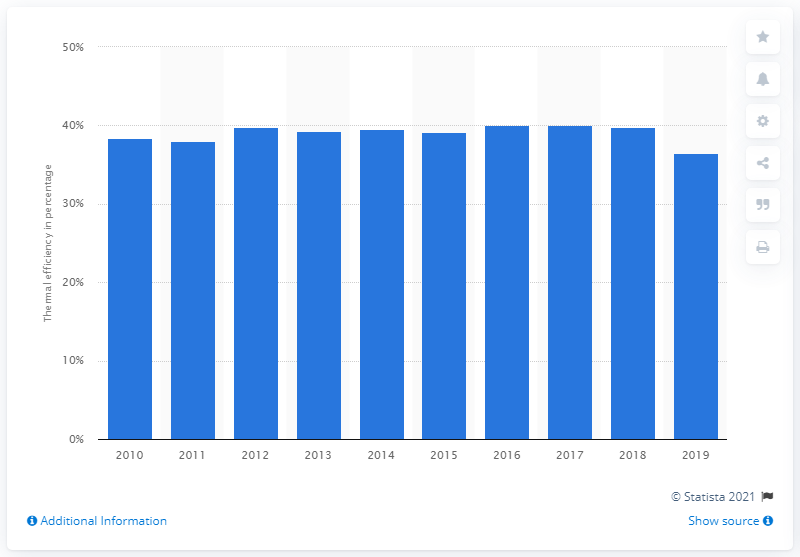Point out several critical features in this image. The thermal efficiency of nuclear power stations in 2019 was 36.5%. 